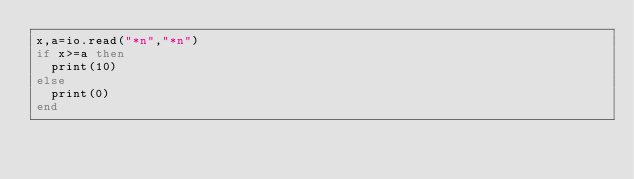<code> <loc_0><loc_0><loc_500><loc_500><_Lua_>x,a=io.read("*n","*n")
if x>=a then
  print(10)
else
  print(0)
end</code> 